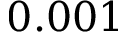Convert formula to latex. <formula><loc_0><loc_0><loc_500><loc_500>0 . 0 0 1</formula> 